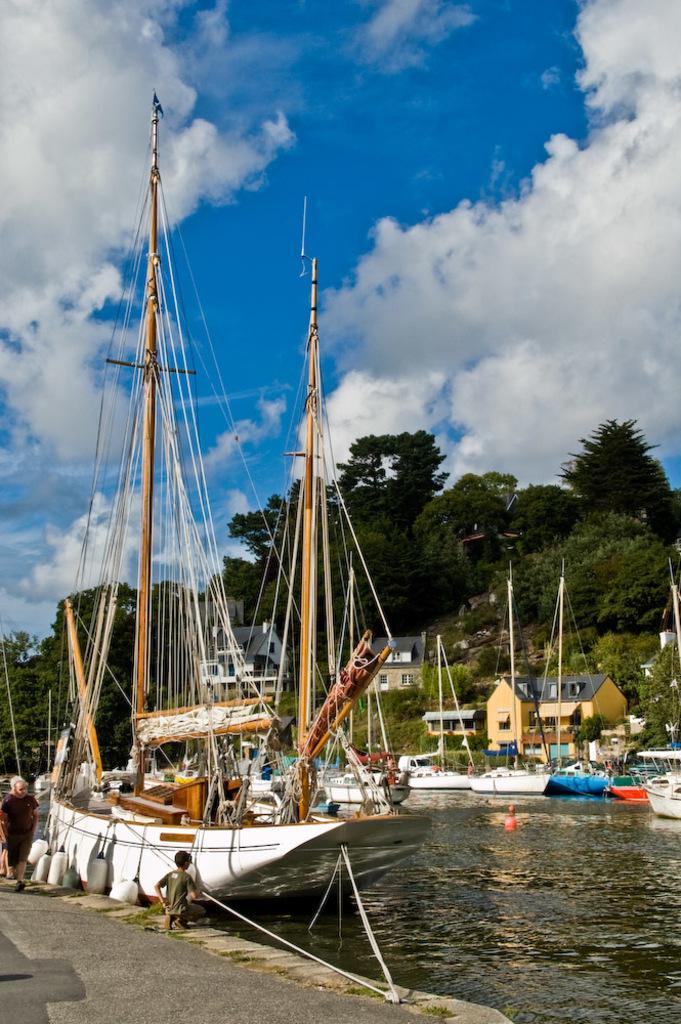Could you give a brief overview of what you see in this image? In this image I can see boats in the water, houses, trees and a group of people on the road. In the background I can see the sky. This image is taken may be during a day. 